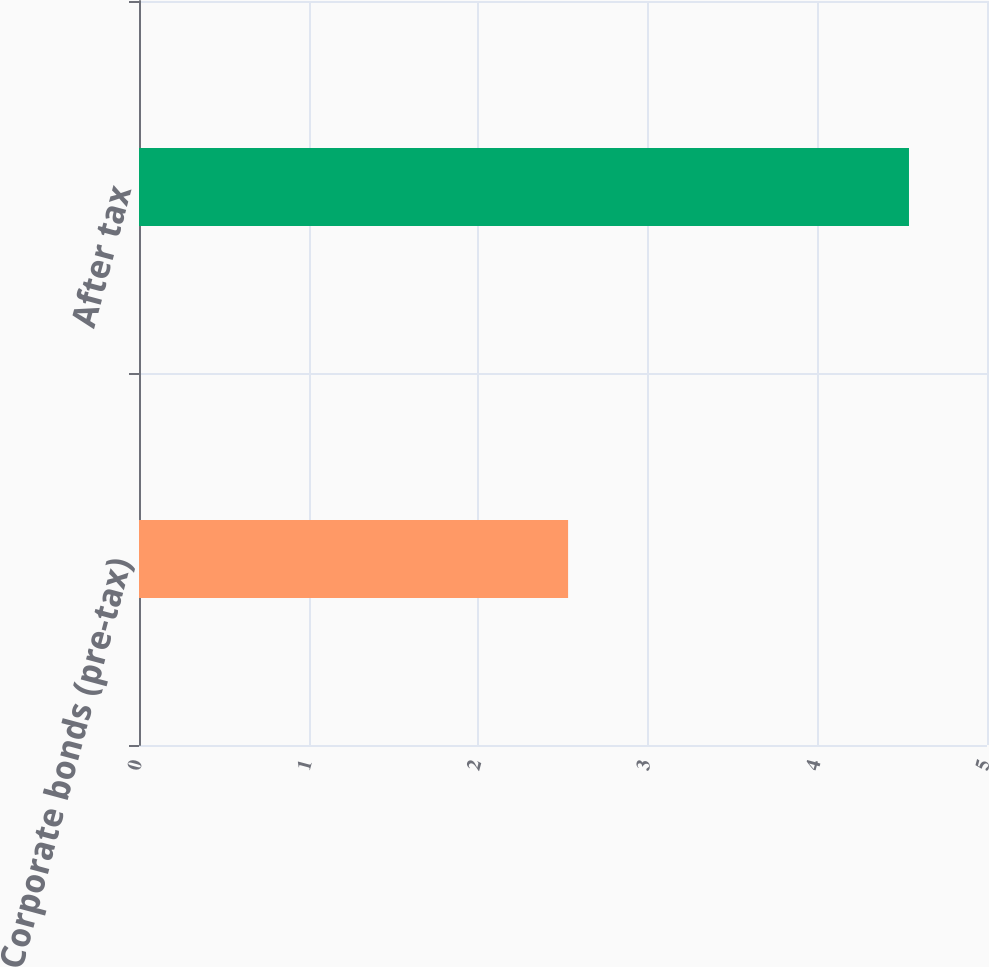Convert chart. <chart><loc_0><loc_0><loc_500><loc_500><bar_chart><fcel>Corporate bonds (pre-tax)<fcel>After tax<nl><fcel>2.53<fcel>4.54<nl></chart> 